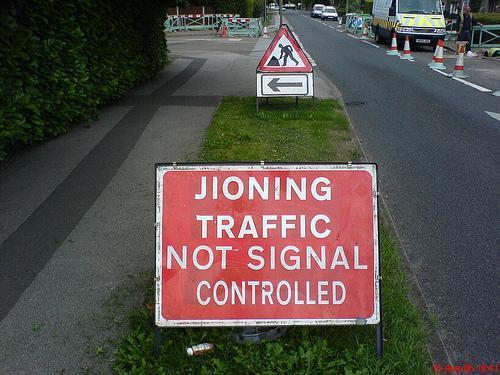How many people are shown?
Give a very brief answer. 1. 